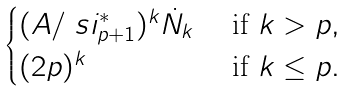<formula> <loc_0><loc_0><loc_500><loc_500>\begin{cases} ( A / \ s i ^ { * } _ { p + 1 } ) ^ { k } \dot { N } _ { k } & \text { if } k > p , \\ ( 2 p ) ^ { k } & \text { if } k \leq p . \end{cases}</formula> 